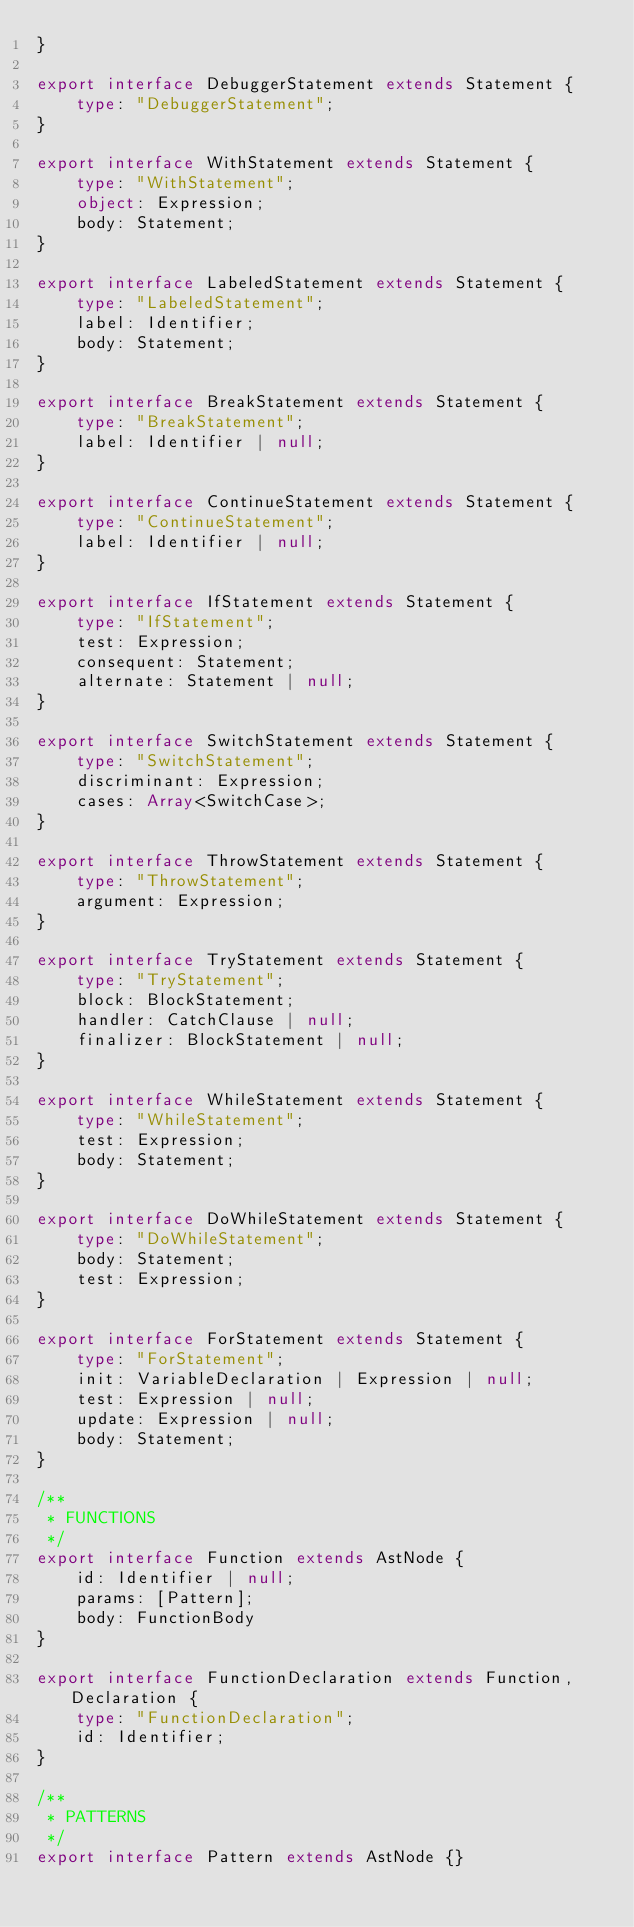Convert code to text. <code><loc_0><loc_0><loc_500><loc_500><_TypeScript_>}

export interface DebuggerStatement extends Statement {
    type: "DebuggerStatement";
}

export interface WithStatement extends Statement {
    type: "WithStatement";
    object: Expression;
    body: Statement;
}

export interface LabeledStatement extends Statement {
    type: "LabeledStatement";
    label: Identifier;
    body: Statement;
}

export interface BreakStatement extends Statement {
    type: "BreakStatement";
    label: Identifier | null;
}

export interface ContinueStatement extends Statement {
    type: "ContinueStatement";
    label: Identifier | null;
}

export interface IfStatement extends Statement {
    type: "IfStatement";
    test: Expression;
    consequent: Statement;
    alternate: Statement | null;
}

export interface SwitchStatement extends Statement {
    type: "SwitchStatement";
    discriminant: Expression;
    cases: Array<SwitchCase>;
}

export interface ThrowStatement extends Statement {
    type: "ThrowStatement";
    argument: Expression;
}

export interface TryStatement extends Statement {
    type: "TryStatement";
    block: BlockStatement;
    handler: CatchClause | null;
    finalizer: BlockStatement | null;
}

export interface WhileStatement extends Statement {
    type: "WhileStatement";
    test: Expression;
    body: Statement;
}

export interface DoWhileStatement extends Statement {
    type: "DoWhileStatement";
    body: Statement;
    test: Expression;
}

export interface ForStatement extends Statement {
    type: "ForStatement";
    init: VariableDeclaration | Expression | null;
    test: Expression | null;
    update: Expression | null;
    body: Statement;
}

/**
 * FUNCTIONS
 */
export interface Function extends AstNode {
    id: Identifier | null;
    params: [Pattern];
    body: FunctionBody
}

export interface FunctionDeclaration extends Function, Declaration {
    type: "FunctionDeclaration";
    id: Identifier;
}

/**
 * PATTERNS
 */
export interface Pattern extends AstNode {}
</code> 